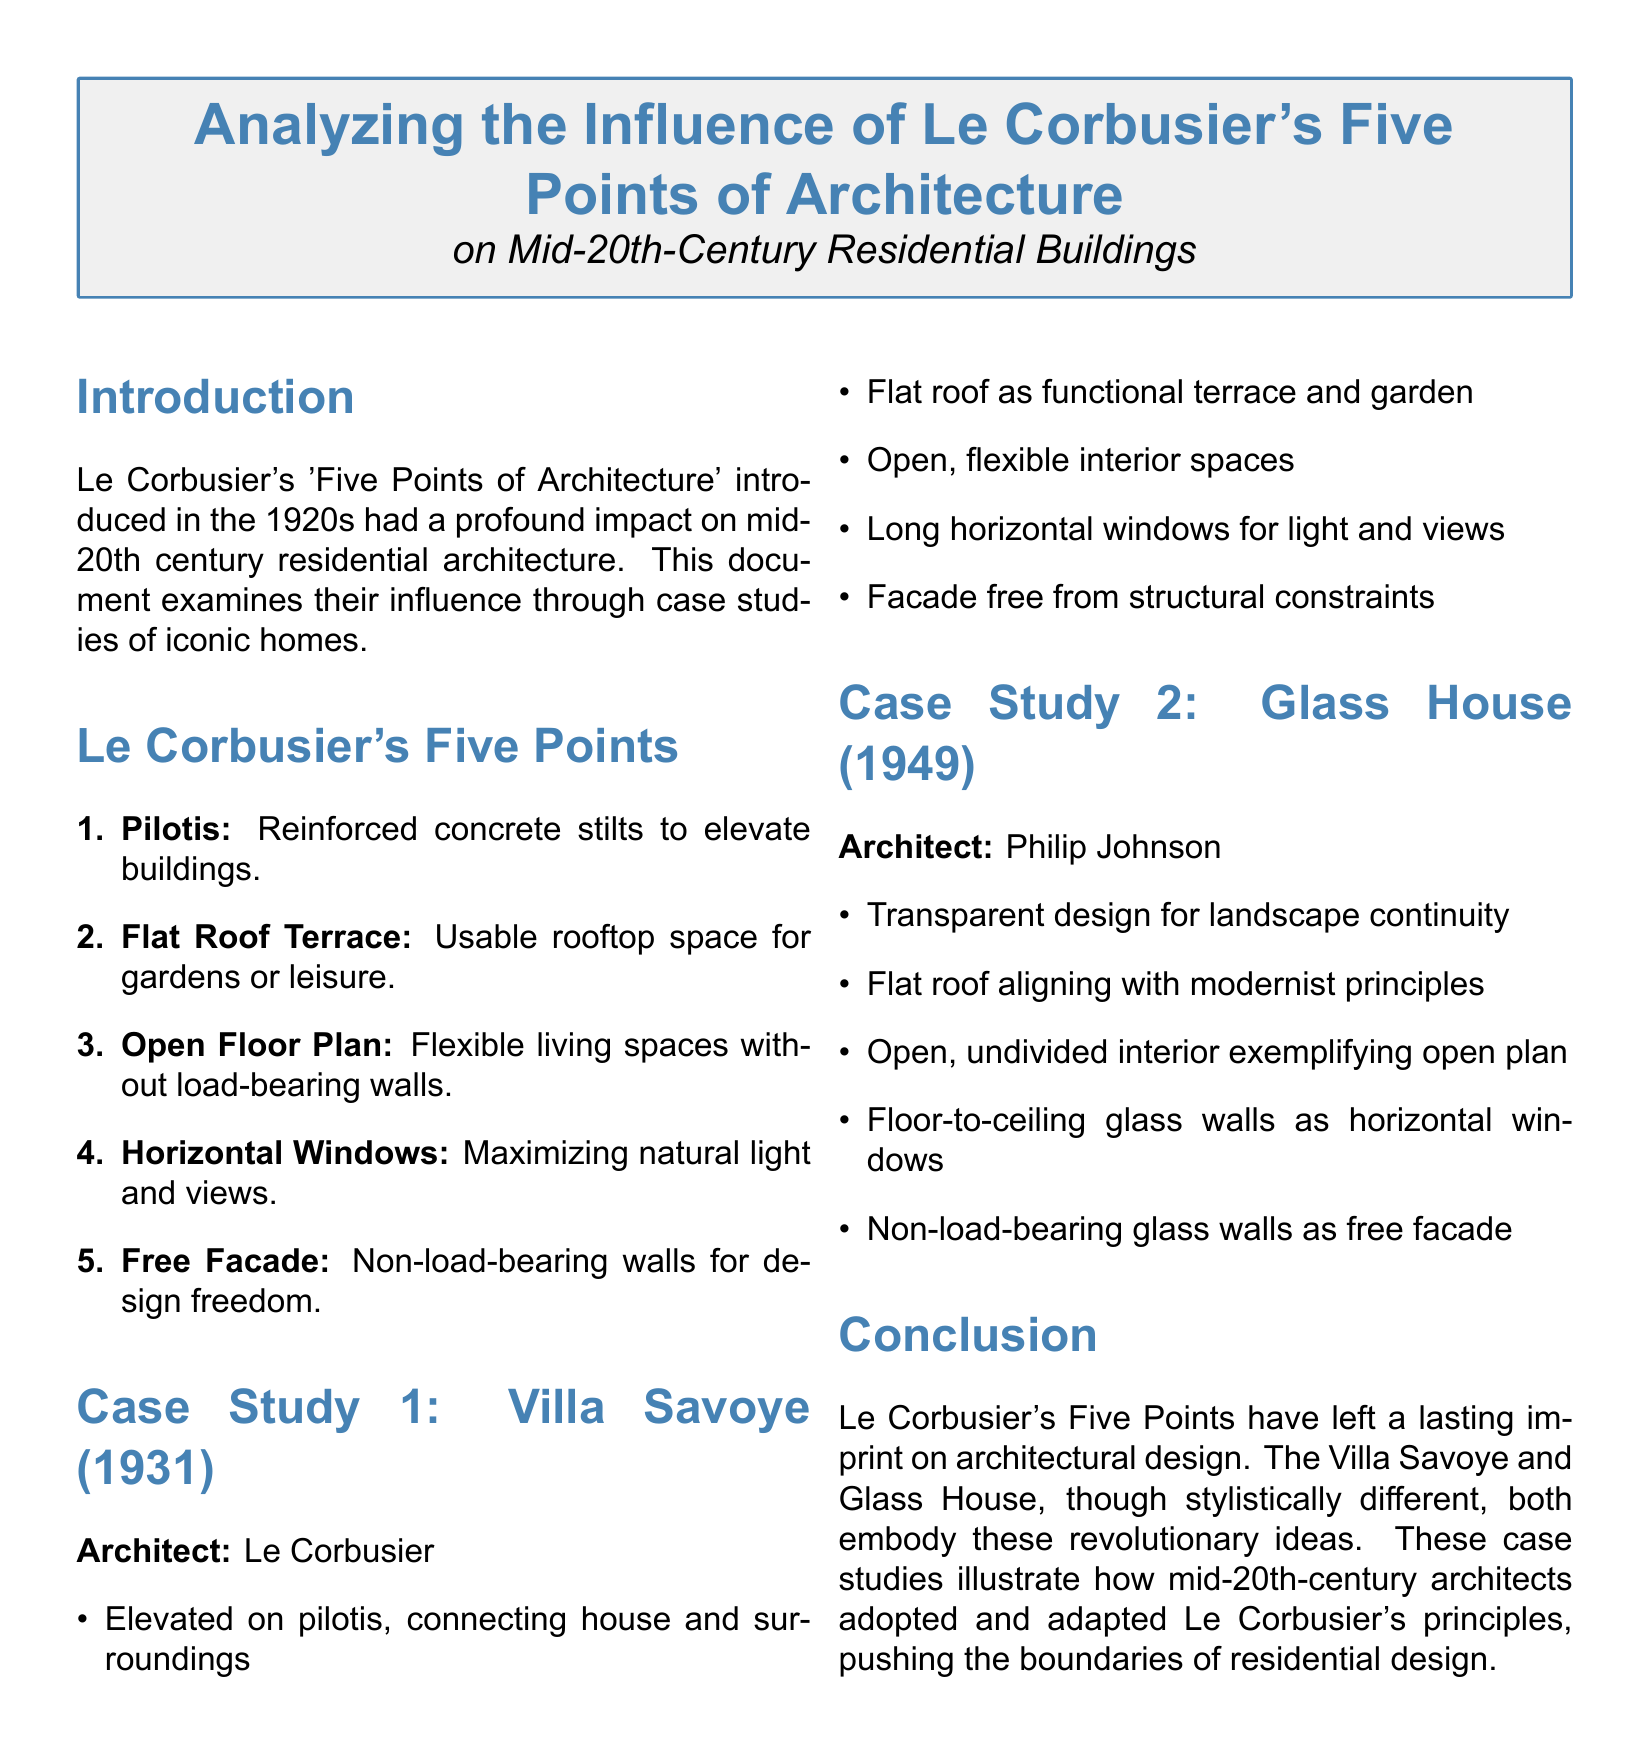What are Le Corbusier's Five Points? The document delineates the Five Points of Architecture which include pilotis, flat roof terrace, open floor plan, horizontal windows, and free facade.
Answer: Pilotis, flat roof terrace, open floor plan, horizontal windows, free facade In what year was Villa Savoye completed? The completion year of Villa Savoye is explicitly stated in the case study section of the document.
Answer: 1931 Which architect designed the Glass House? The architect responsible for the Glass House is indicated in the respective case study of the document.
Answer: Philip Johnson What design principle emphasizes flexible living spaces? The principle related to flexible living spaces is highlighted among Le Corbusier's Five Points within the document.
Answer: Open Floor Plan What element connects the house and surroundings in Villa Savoye? The aspect that connects Villa Savoye with its surroundings is mentioned in the case study details.
Answer: Pilotis How does the Glass House incorporate natural light? The method by which the Glass House maximizes natural light is specified in its case study.
Answer: Floor-to-ceiling glass walls What does the flat roof in these designs provide? The document explains the functionality of the flat roof as a garden or leisure space.
Answer: Usable rooftop space Which architectural feature allows design freedom? The document specifies which aspect permits architectural design freedom among the Five Points of Architecture.
Answer: Free Facade 